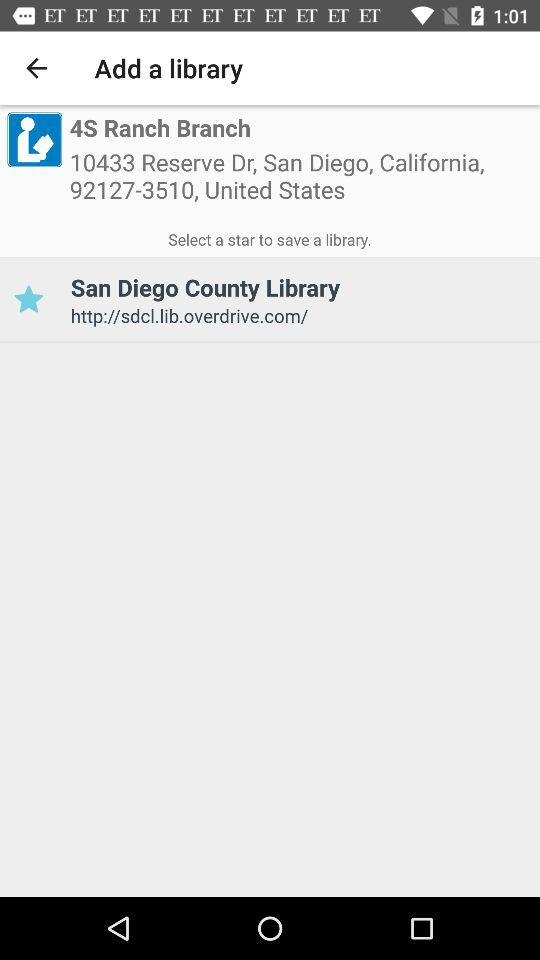What is the address of the library? The address is 10433 Reserve Dr, San Diego, California, 92127-3510, United States. 